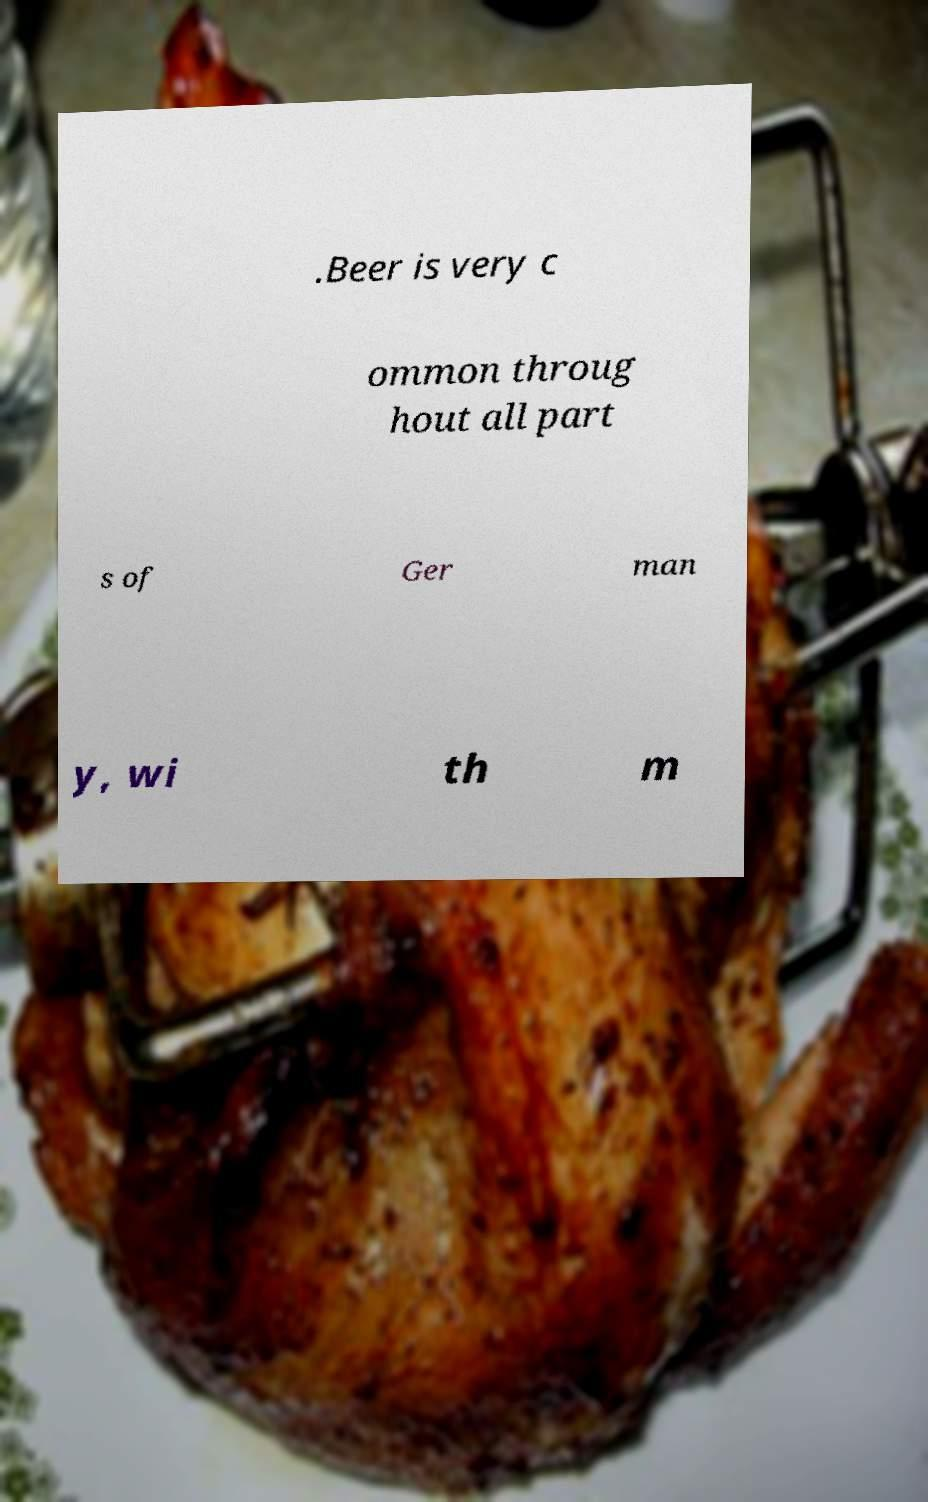I need the written content from this picture converted into text. Can you do that? .Beer is very c ommon throug hout all part s of Ger man y, wi th m 